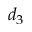<formula> <loc_0><loc_0><loc_500><loc_500>d _ { 3 }</formula> 